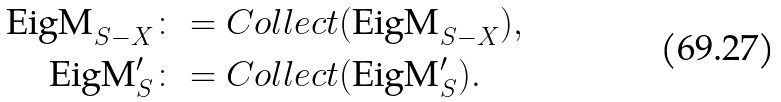Convert formula to latex. <formula><loc_0><loc_0><loc_500><loc_500>\text {EigM} _ { S - X } & \colon = C o l l e c t ( \text {EigM} _ { S - X } ) , \\ \text {EigM} ^ { \prime } _ { S } & \colon = C o l l e c t ( \text {EigM} ^ { \prime } _ { S } ) .</formula> 